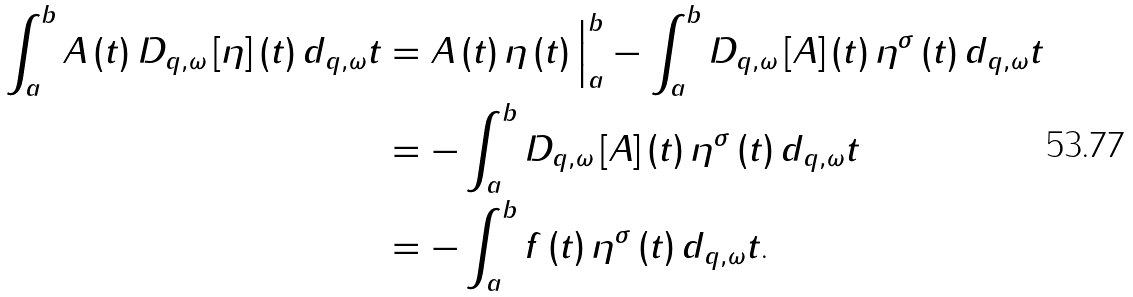<formula> <loc_0><loc_0><loc_500><loc_500>\int _ { a } ^ { b } A \left ( t \right ) D _ { q , \omega } \left [ \eta \right ] \left ( t \right ) d _ { q , \omega } t & = A \left ( t \right ) \eta \left ( t \right ) \Big | _ { a } ^ { b } - \int _ { a } ^ { b } D _ { q , \omega } \left [ A \right ] \left ( t \right ) \eta ^ { \sigma } \left ( t \right ) d _ { q , \omega } t \\ & = - \int _ { a } ^ { b } D _ { q , \omega } \left [ A \right ] \left ( t \right ) \eta ^ { \sigma } \left ( t \right ) d _ { q , \omega } t \\ & = - \int _ { a } ^ { b } f \left ( t \right ) \eta ^ { \sigma } \left ( t \right ) d _ { q , \omega } t \text {.}</formula> 